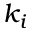Convert formula to latex. <formula><loc_0><loc_0><loc_500><loc_500>k _ { i }</formula> 